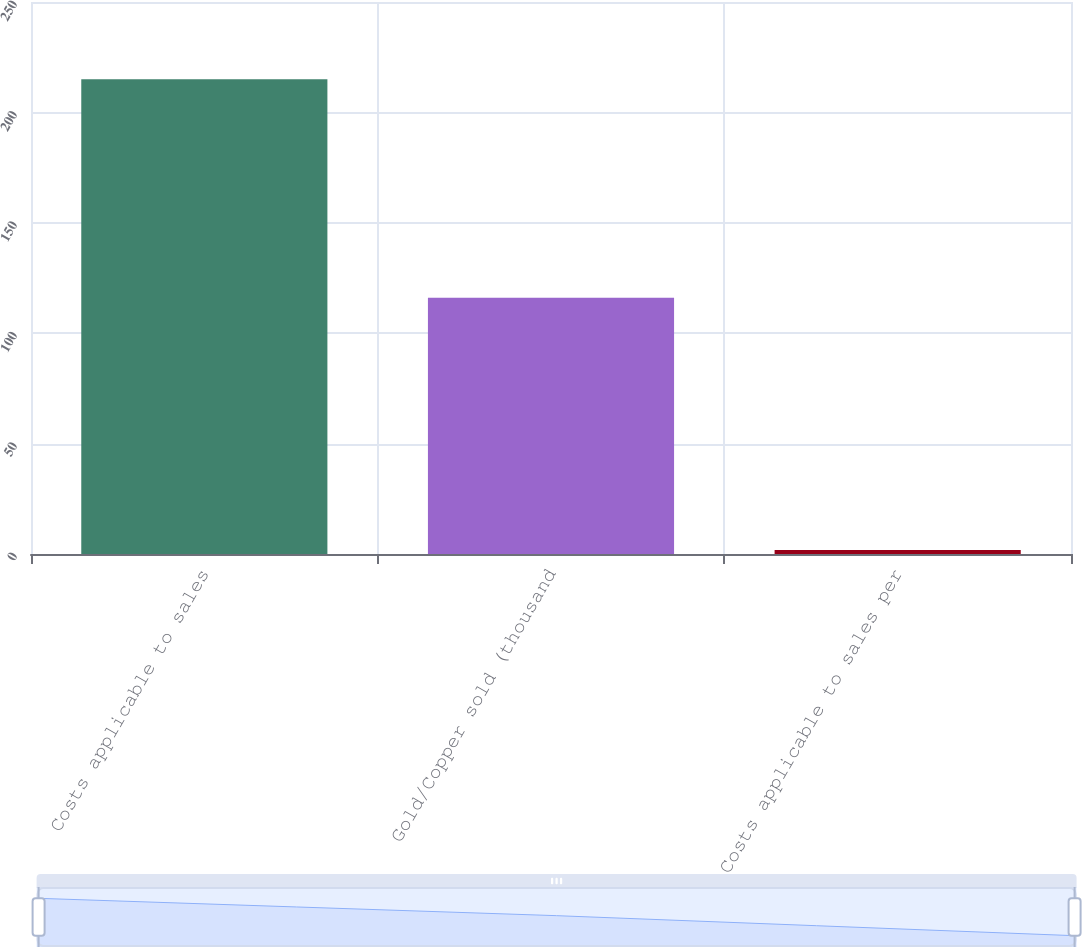Convert chart. <chart><loc_0><loc_0><loc_500><loc_500><bar_chart><fcel>Costs applicable to sales<fcel>Gold/Copper sold (thousand<fcel>Costs applicable to sales per<nl><fcel>215<fcel>116<fcel>1.85<nl></chart> 